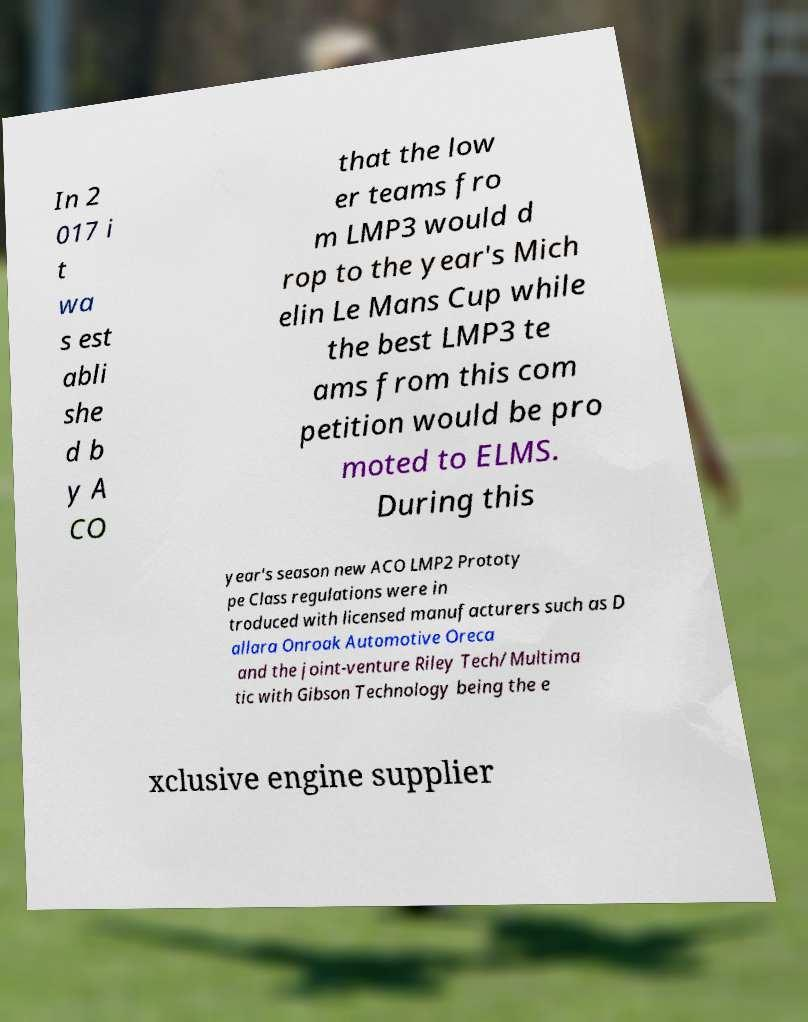Can you read and provide the text displayed in the image?This photo seems to have some interesting text. Can you extract and type it out for me? In 2 017 i t wa s est abli she d b y A CO that the low er teams fro m LMP3 would d rop to the year's Mich elin Le Mans Cup while the best LMP3 te ams from this com petition would be pro moted to ELMS. During this year's season new ACO LMP2 Prototy pe Class regulations were in troduced with licensed manufacturers such as D allara Onroak Automotive Oreca and the joint-venture Riley Tech/Multima tic with Gibson Technology being the e xclusive engine supplier 